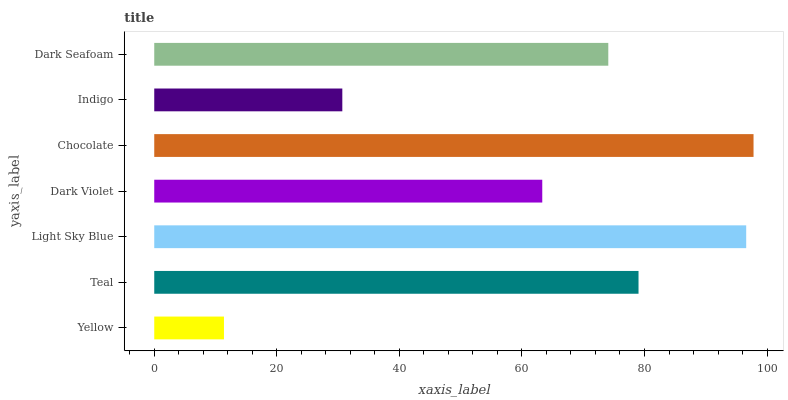Is Yellow the minimum?
Answer yes or no. Yes. Is Chocolate the maximum?
Answer yes or no. Yes. Is Teal the minimum?
Answer yes or no. No. Is Teal the maximum?
Answer yes or no. No. Is Teal greater than Yellow?
Answer yes or no. Yes. Is Yellow less than Teal?
Answer yes or no. Yes. Is Yellow greater than Teal?
Answer yes or no. No. Is Teal less than Yellow?
Answer yes or no. No. Is Dark Seafoam the high median?
Answer yes or no. Yes. Is Dark Seafoam the low median?
Answer yes or no. Yes. Is Indigo the high median?
Answer yes or no. No. Is Teal the low median?
Answer yes or no. No. 